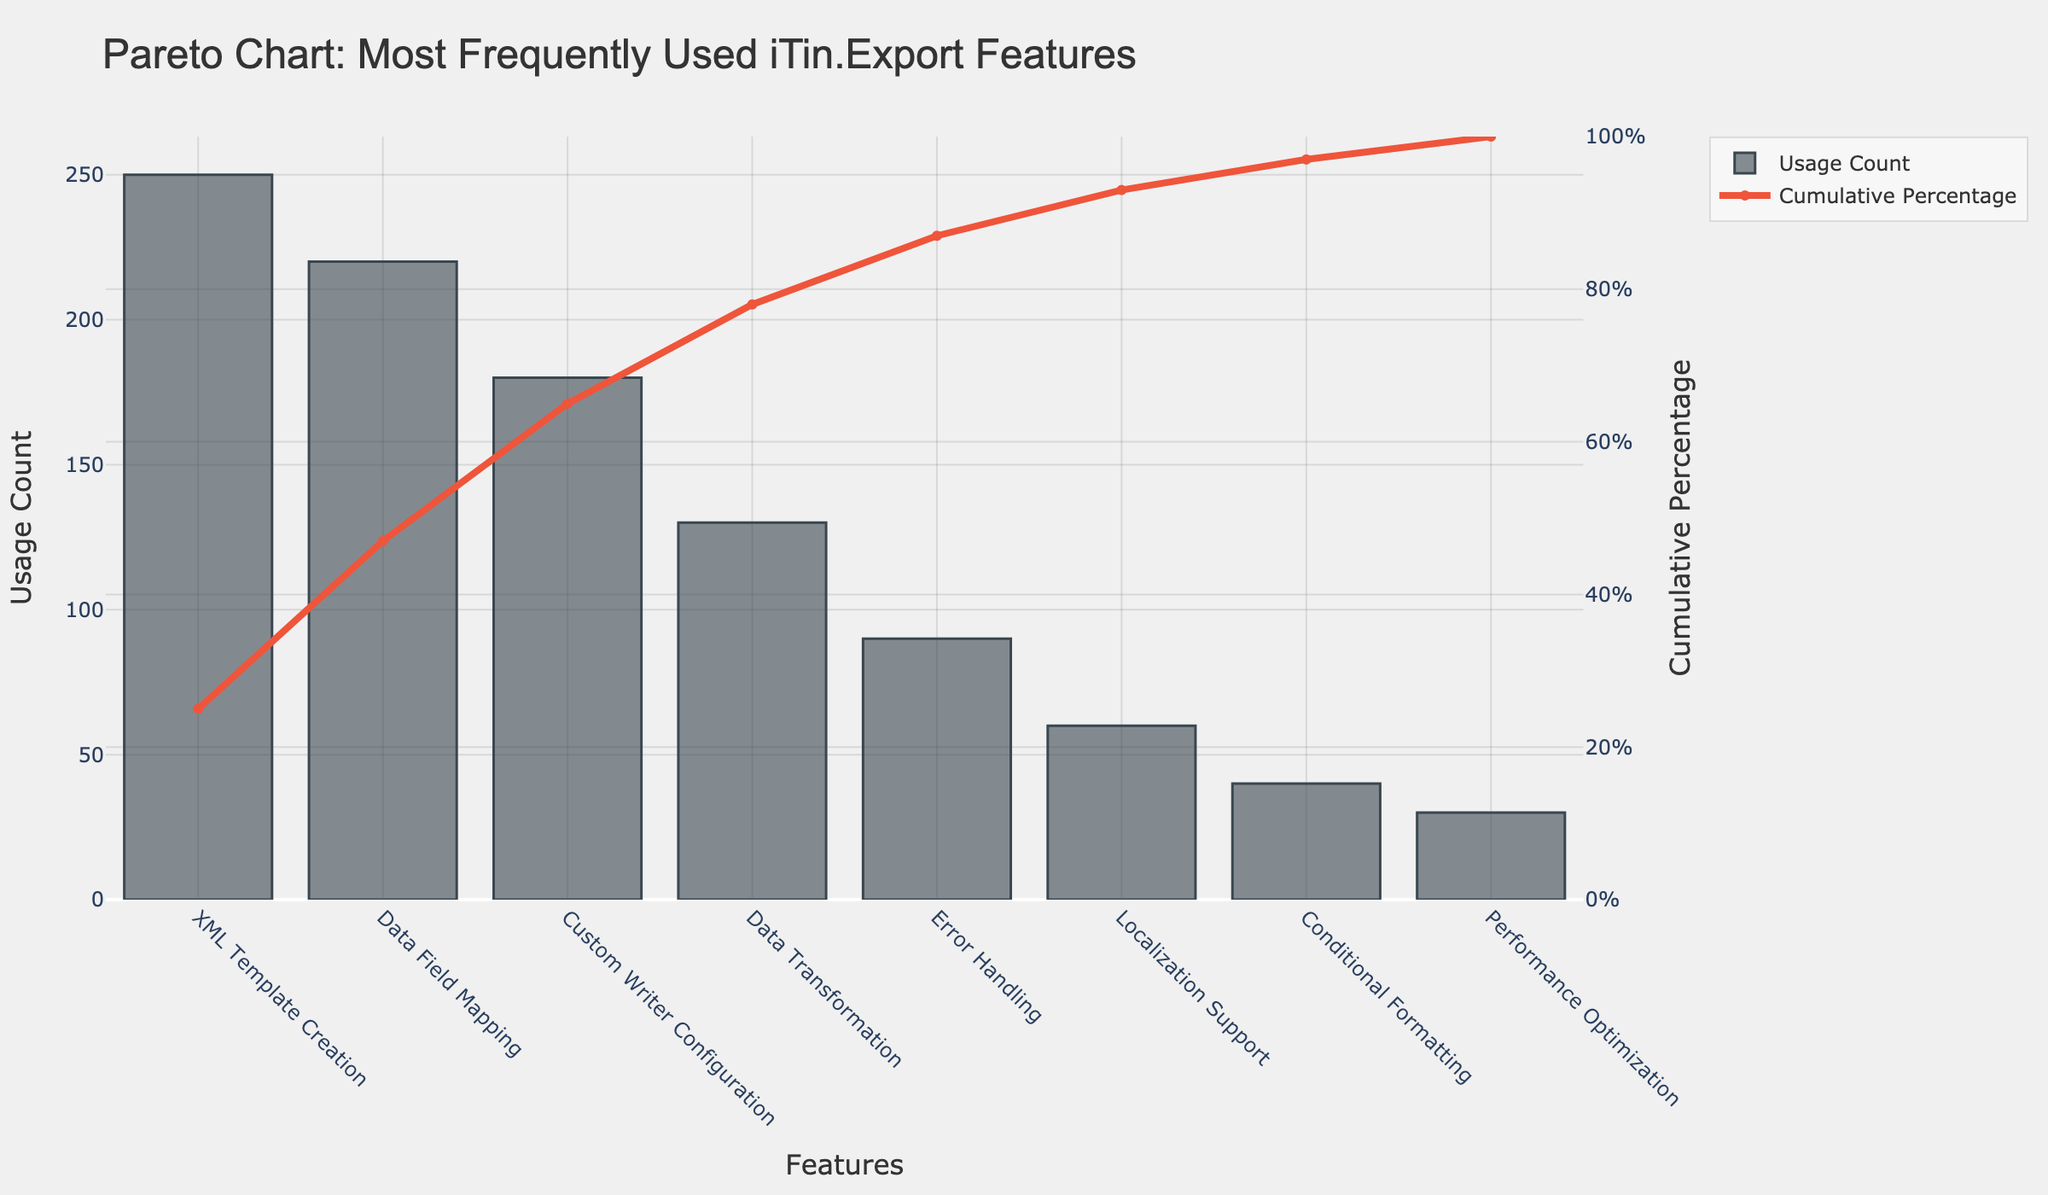How many features are listed on the Pareto chart? Count the number of bars displayed on the Pareto chart, each representing a feature.
Answer: 8 Which feature has the highest usage count? Identify the first bar from the left on the chart, which represents the feature with the highest usage count.
Answer: XML Template Creation What is the cumulative percentage after including the "Data Field Mapping" feature? Look for the cumulative percentage line corresponding to the "Data Field Mapping" feature.
Answer: 47.0% Which feature's usage contributes to crossing the 50% cumulative percentage mark? Observe the cumulative percentage line and find the feature just after crossing 50%.
Answer: Custom Writer Configuration By how much does the usage count of "Custom Writer Configuration" exceed that of "Localization Support"? Subtract the usage count of "Localization Support" from the usage count of "Custom Writer Configuration" (180 - 60).
Answer: 120 What percentage of the total usage do the top three features contribute? Add the cumulative percentages of the top three features: XML Template Creation (25.0%) + Data Field Mapping (22.0%) + Custom Writer Configuration (18.0%) to get the cumulative percentage after the third feature.
Answer: 65.0% Which feature appears last on the Pareto chart and what is its usage count? Identify the last bar from the right on the Pareto chart and refer to its height for the usage count.
Answer: Performance Optimization, 30 Compare the cumulative percentage increase between "Error Handling" and "Localization Support". Subtract the cumulative percentage of "Error Handling" from that of "Localization Support" (93.0% - 87.0%).
Answer: 6.0% 